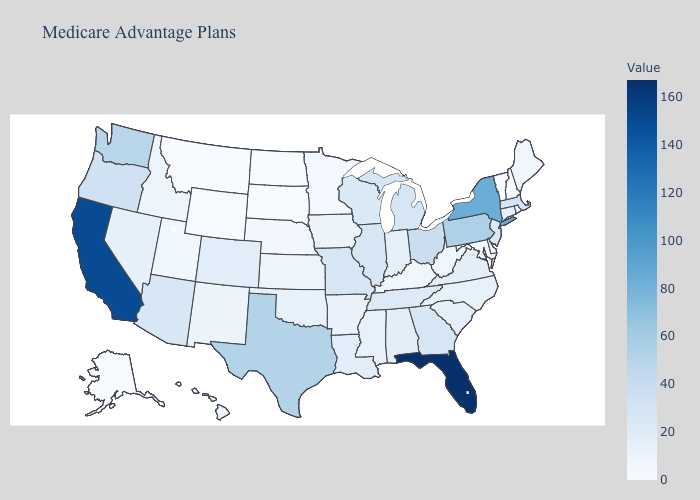Among the states that border Tennessee , which have the highest value?
Be succinct. Georgia, Missouri. Which states hav the highest value in the South?
Be succinct. Florida. Among the states that border Rhode Island , which have the lowest value?
Keep it brief. Connecticut. Among the states that border Alabama , which have the highest value?
Short answer required. Florida. Is the legend a continuous bar?
Quick response, please. Yes. Is the legend a continuous bar?
Quick response, please. Yes. Does Ohio have the highest value in the MidWest?
Quick response, please. Yes. 